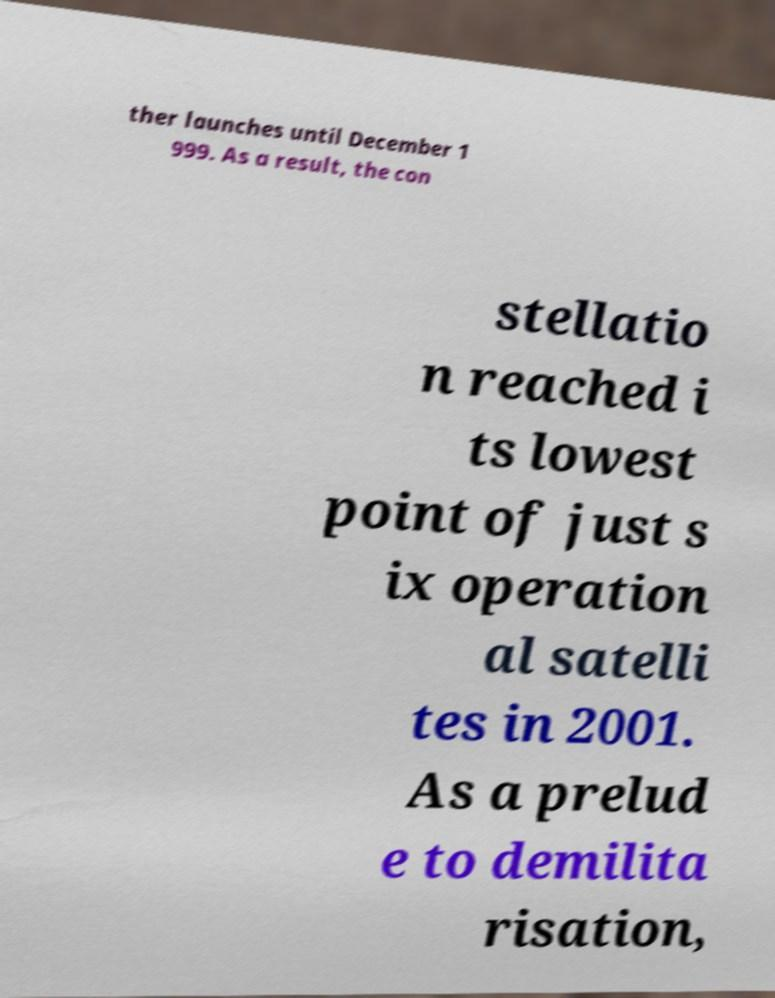What messages or text are displayed in this image? I need them in a readable, typed format. ther launches until December 1 999. As a result, the con stellatio n reached i ts lowest point of just s ix operation al satelli tes in 2001. As a prelud e to demilita risation, 